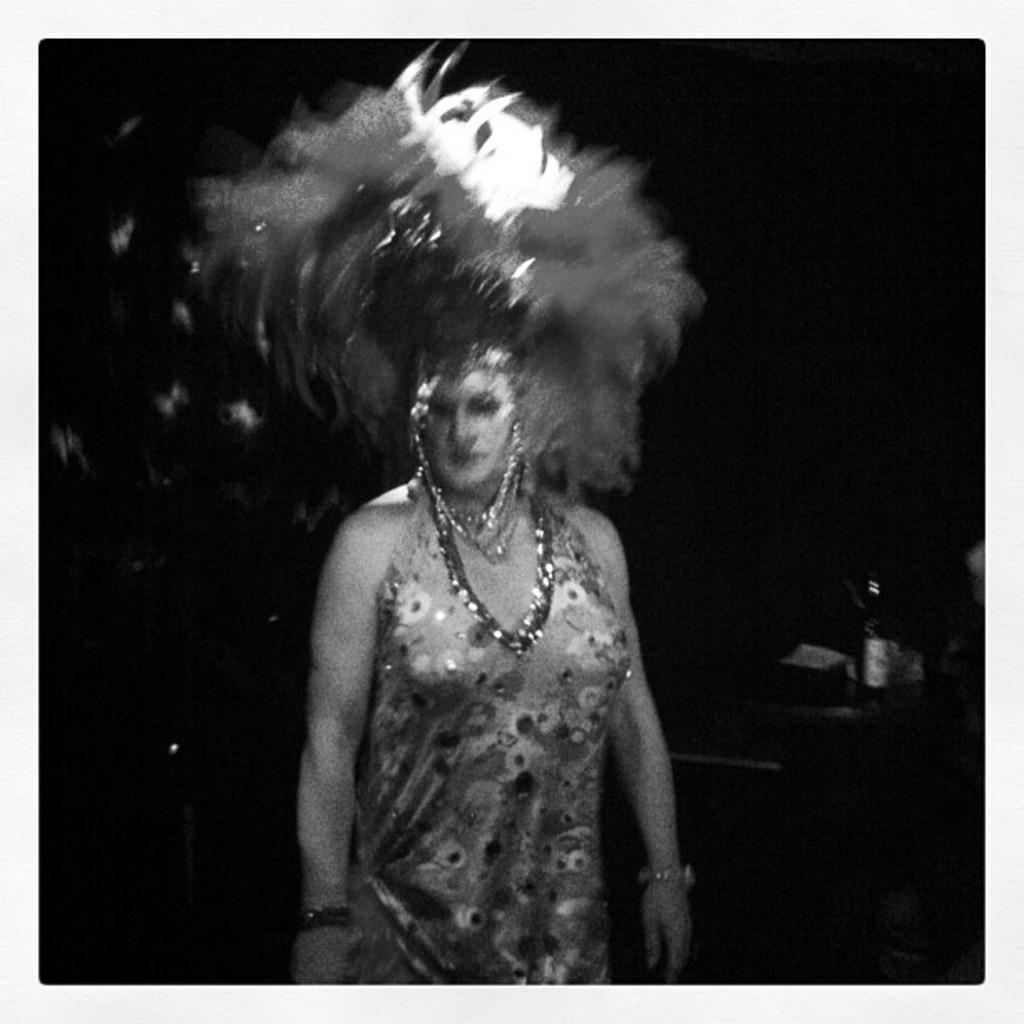What is the main subject of the image? There is a woman standing in the image. What object can be seen on the right side of the image? There is a bottle on the right side of the image. How would you describe the background of the image? The background of the image is dark. What color scheme is used in the image? The image is black and white. What type of map can be seen on the table in the image? There is no map present in the image; it features a woman standing and a bottle on the right side. How many mice are visible on the woman's shoulder in the image? There are no mice present in the image. 